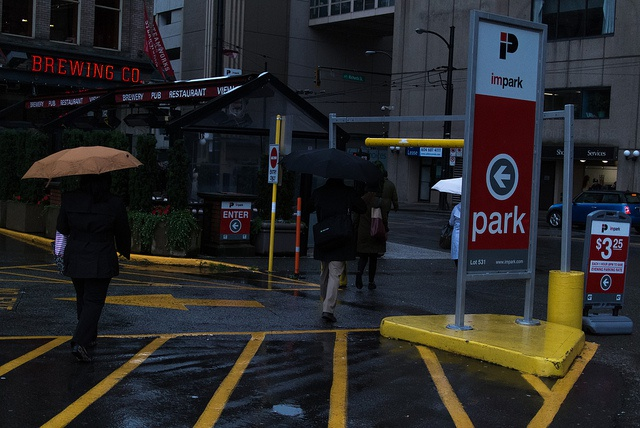Describe the objects in this image and their specific colors. I can see people in black, olive, and purple tones, people in black and gray tones, people in black, gray, and darkblue tones, umbrella in black, brown, and gray tones, and umbrella in black, navy, darkblue, and blue tones in this image. 